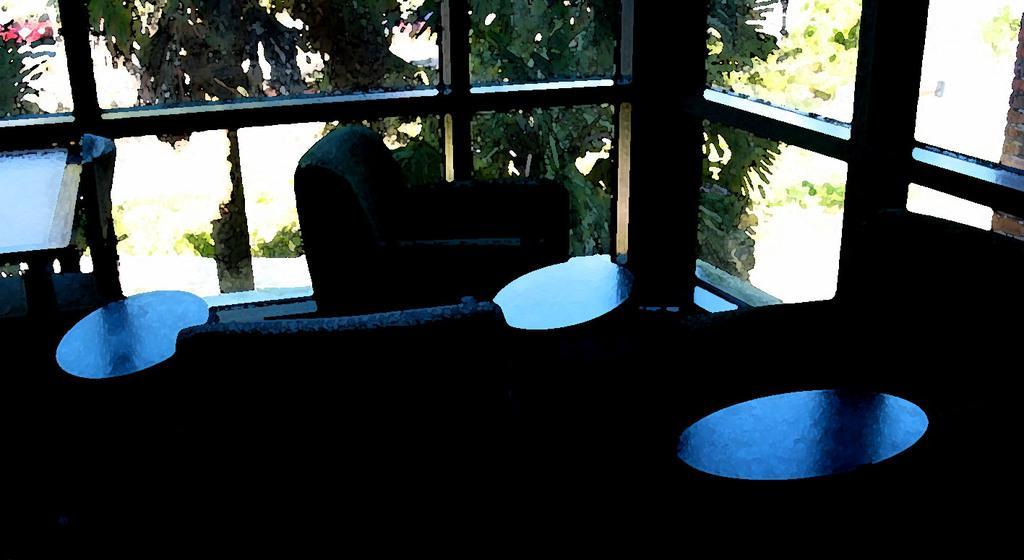Describe this image in one or two sentences. In the picture I can see the tables and sofas on the floor. In the background, I can see the glass windows and trees. 